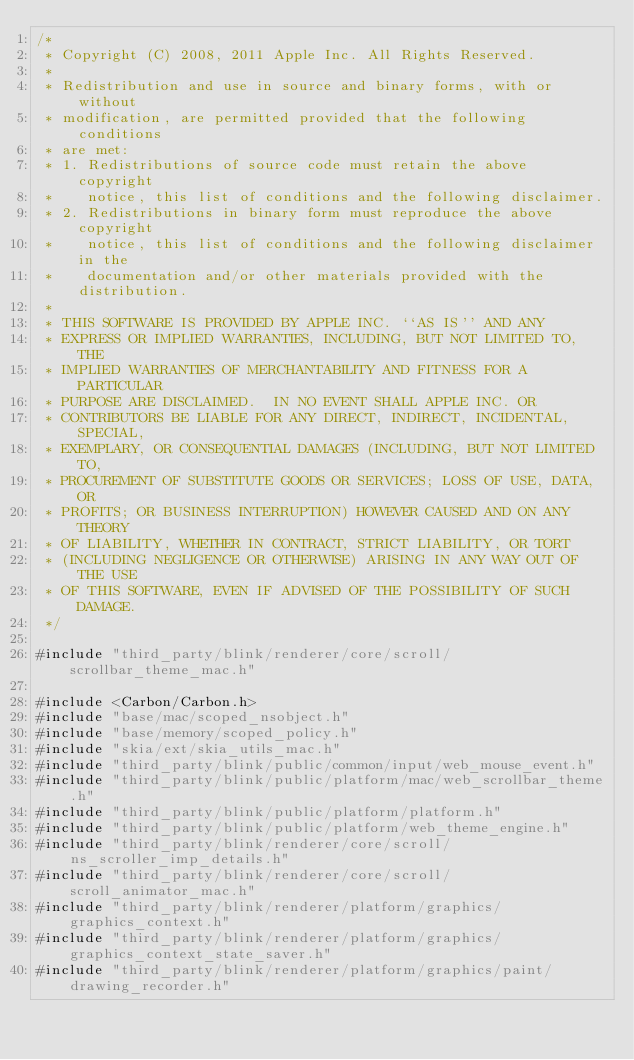<code> <loc_0><loc_0><loc_500><loc_500><_ObjectiveC_>/*
 * Copyright (C) 2008, 2011 Apple Inc. All Rights Reserved.
 *
 * Redistribution and use in source and binary forms, with or without
 * modification, are permitted provided that the following conditions
 * are met:
 * 1. Redistributions of source code must retain the above copyright
 *    notice, this list of conditions and the following disclaimer.
 * 2. Redistributions in binary form must reproduce the above copyright
 *    notice, this list of conditions and the following disclaimer in the
 *    documentation and/or other materials provided with the distribution.
 *
 * THIS SOFTWARE IS PROVIDED BY APPLE INC. ``AS IS'' AND ANY
 * EXPRESS OR IMPLIED WARRANTIES, INCLUDING, BUT NOT LIMITED TO, THE
 * IMPLIED WARRANTIES OF MERCHANTABILITY AND FITNESS FOR A PARTICULAR
 * PURPOSE ARE DISCLAIMED.  IN NO EVENT SHALL APPLE INC. OR
 * CONTRIBUTORS BE LIABLE FOR ANY DIRECT, INDIRECT, INCIDENTAL, SPECIAL,
 * EXEMPLARY, OR CONSEQUENTIAL DAMAGES (INCLUDING, BUT NOT LIMITED TO,
 * PROCUREMENT OF SUBSTITUTE GOODS OR SERVICES; LOSS OF USE, DATA, OR
 * PROFITS; OR BUSINESS INTERRUPTION) HOWEVER CAUSED AND ON ANY THEORY
 * OF LIABILITY, WHETHER IN CONTRACT, STRICT LIABILITY, OR TORT
 * (INCLUDING NEGLIGENCE OR OTHERWISE) ARISING IN ANY WAY OUT OF THE USE
 * OF THIS SOFTWARE, EVEN IF ADVISED OF THE POSSIBILITY OF SUCH DAMAGE.
 */

#include "third_party/blink/renderer/core/scroll/scrollbar_theme_mac.h"

#include <Carbon/Carbon.h>
#include "base/mac/scoped_nsobject.h"
#include "base/memory/scoped_policy.h"
#include "skia/ext/skia_utils_mac.h"
#include "third_party/blink/public/common/input/web_mouse_event.h"
#include "third_party/blink/public/platform/mac/web_scrollbar_theme.h"
#include "third_party/blink/public/platform/platform.h"
#include "third_party/blink/public/platform/web_theme_engine.h"
#include "third_party/blink/renderer/core/scroll/ns_scroller_imp_details.h"
#include "third_party/blink/renderer/core/scroll/scroll_animator_mac.h"
#include "third_party/blink/renderer/platform/graphics/graphics_context.h"
#include "third_party/blink/renderer/platform/graphics/graphics_context_state_saver.h"
#include "third_party/blink/renderer/platform/graphics/paint/drawing_recorder.h"</code> 